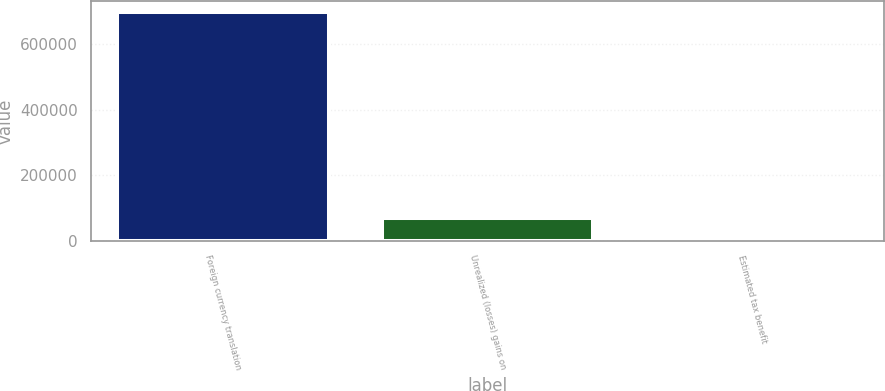<chart> <loc_0><loc_0><loc_500><loc_500><bar_chart><fcel>Foreign currency translation<fcel>Unrealized (losses) gains on<fcel>Estimated tax benefit<nl><fcel>696458<fcel>69879.8<fcel>260<nl></chart> 